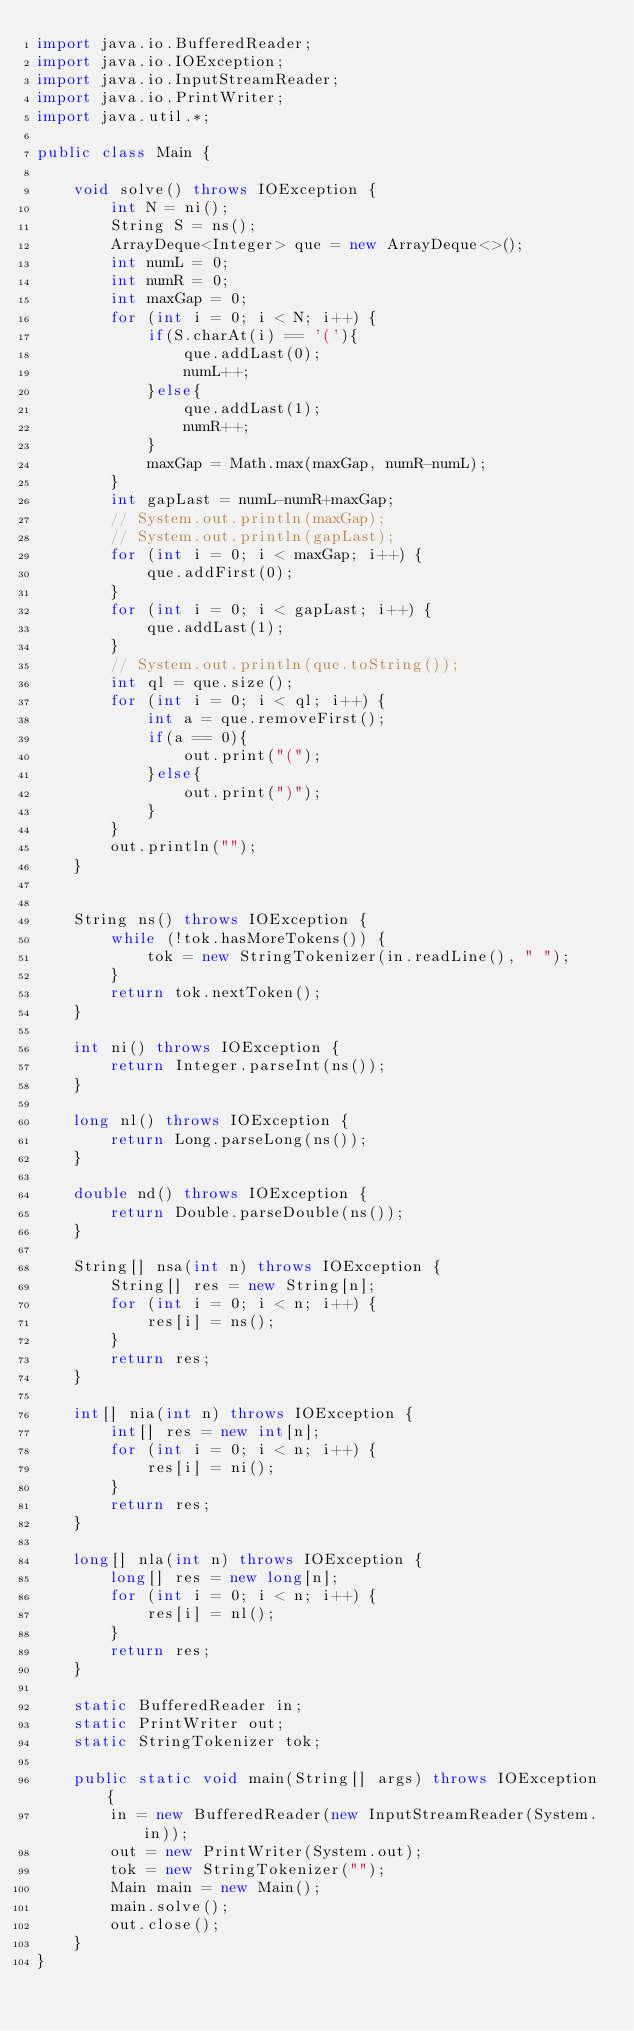Convert code to text. <code><loc_0><loc_0><loc_500><loc_500><_Java_>import java.io.BufferedReader;
import java.io.IOException;
import java.io.InputStreamReader;
import java.io.PrintWriter;
import java.util.*;
 
public class Main {
 
    void solve() throws IOException {
        int N = ni();
        String S = ns();
        ArrayDeque<Integer> que = new ArrayDeque<>();
        int numL = 0;
        int numR = 0;
        int maxGap = 0;
        for (int i = 0; i < N; i++) {
            if(S.charAt(i) == '('){
                que.addLast(0);
                numL++;
            }else{
                que.addLast(1);
                numR++;
            }
            maxGap = Math.max(maxGap, numR-numL);
        }
        int gapLast = numL-numR+maxGap;
        // System.out.println(maxGap);
        // System.out.println(gapLast);
        for (int i = 0; i < maxGap; i++) {
            que.addFirst(0);
        }
        for (int i = 0; i < gapLast; i++) {
            que.addLast(1);
        }
        // System.out.println(que.toString());
        int ql = que.size();
        for (int i = 0; i < ql; i++) {
            int a = que.removeFirst();
            if(a == 0){
                out.print("(");
            }else{
                out.print(")");
            }
        }
        out.println("");
    }

 
    String ns() throws IOException {
        while (!tok.hasMoreTokens()) {
            tok = new StringTokenizer(in.readLine(), " ");
        }
        return tok.nextToken();
    }
 
    int ni() throws IOException {
        return Integer.parseInt(ns());
    }
 
    long nl() throws IOException {
        return Long.parseLong(ns());
    }
 
    double nd() throws IOException {
        return Double.parseDouble(ns());
    }
 
    String[] nsa(int n) throws IOException {
        String[] res = new String[n];
        for (int i = 0; i < n; i++) {
            res[i] = ns();
        }
        return res;
    }
 
    int[] nia(int n) throws IOException {
        int[] res = new int[n];
        for (int i = 0; i < n; i++) {
            res[i] = ni();
        }
        return res;
    }
 
    long[] nla(int n) throws IOException {
        long[] res = new long[n];
        for (int i = 0; i < n; i++) {
            res[i] = nl();
        }
        return res;
    }
 
    static BufferedReader in;
    static PrintWriter out;
    static StringTokenizer tok;
 
    public static void main(String[] args) throws IOException {
        in = new BufferedReader(new InputStreamReader(System.in));
        out = new PrintWriter(System.out);
        tok = new StringTokenizer("");
        Main main = new Main();
        main.solve();
        out.close();
    }
}</code> 